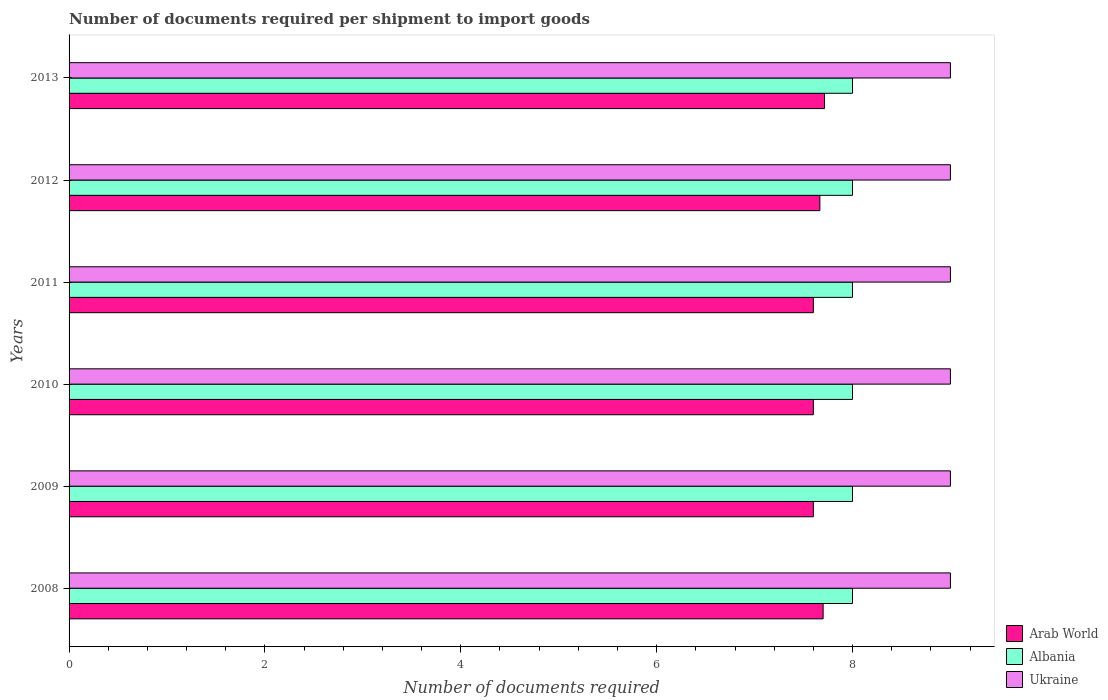How many different coloured bars are there?
Your response must be concise. 3. How many groups of bars are there?
Your response must be concise. 6. Are the number of bars per tick equal to the number of legend labels?
Ensure brevity in your answer.  Yes. What is the number of documents required per shipment to import goods in Ukraine in 2012?
Keep it short and to the point. 9. Across all years, what is the maximum number of documents required per shipment to import goods in Arab World?
Provide a short and direct response. 7.71. Across all years, what is the minimum number of documents required per shipment to import goods in Ukraine?
Your answer should be very brief. 9. In which year was the number of documents required per shipment to import goods in Ukraine maximum?
Provide a succinct answer. 2008. What is the total number of documents required per shipment to import goods in Albania in the graph?
Provide a short and direct response. 48. What is the difference between the number of documents required per shipment to import goods in Arab World in 2009 and that in 2012?
Provide a succinct answer. -0.07. What is the difference between the number of documents required per shipment to import goods in Albania in 2009 and the number of documents required per shipment to import goods in Ukraine in 2013?
Your response must be concise. -1. What is the average number of documents required per shipment to import goods in Arab World per year?
Provide a succinct answer. 7.65. In the year 2008, what is the difference between the number of documents required per shipment to import goods in Ukraine and number of documents required per shipment to import goods in Albania?
Your answer should be very brief. 1. In how many years, is the number of documents required per shipment to import goods in Arab World greater than 1.2000000000000002 ?
Give a very brief answer. 6. What is the ratio of the number of documents required per shipment to import goods in Ukraine in 2009 to that in 2012?
Keep it short and to the point. 1. What is the difference between the highest and the second highest number of documents required per shipment to import goods in Arab World?
Your answer should be compact. 0.01. What is the difference between the highest and the lowest number of documents required per shipment to import goods in Ukraine?
Make the answer very short. 0. Is the sum of the number of documents required per shipment to import goods in Arab World in 2009 and 2012 greater than the maximum number of documents required per shipment to import goods in Ukraine across all years?
Provide a succinct answer. Yes. What does the 1st bar from the top in 2008 represents?
Your response must be concise. Ukraine. What does the 1st bar from the bottom in 2011 represents?
Your answer should be very brief. Arab World. Are the values on the major ticks of X-axis written in scientific E-notation?
Offer a very short reply. No. Does the graph contain grids?
Offer a terse response. No. Where does the legend appear in the graph?
Provide a succinct answer. Bottom right. What is the title of the graph?
Your answer should be compact. Number of documents required per shipment to import goods. What is the label or title of the X-axis?
Keep it short and to the point. Number of documents required. What is the Number of documents required in Albania in 2008?
Provide a succinct answer. 8. What is the Number of documents required in Ukraine in 2008?
Provide a succinct answer. 9. What is the Number of documents required in Arab World in 2009?
Offer a very short reply. 7.6. What is the Number of documents required in Albania in 2009?
Give a very brief answer. 8. What is the Number of documents required of Arab World in 2011?
Your response must be concise. 7.6. What is the Number of documents required in Albania in 2011?
Make the answer very short. 8. What is the Number of documents required in Ukraine in 2011?
Provide a succinct answer. 9. What is the Number of documents required of Arab World in 2012?
Provide a short and direct response. 7.67. What is the Number of documents required in Arab World in 2013?
Give a very brief answer. 7.71. What is the Number of documents required of Ukraine in 2013?
Your answer should be compact. 9. Across all years, what is the maximum Number of documents required in Arab World?
Give a very brief answer. 7.71. Across all years, what is the maximum Number of documents required of Albania?
Your response must be concise. 8. Across all years, what is the maximum Number of documents required in Ukraine?
Provide a short and direct response. 9. What is the total Number of documents required in Arab World in the graph?
Offer a terse response. 45.88. What is the total Number of documents required in Albania in the graph?
Keep it short and to the point. 48. What is the difference between the Number of documents required in Arab World in 2008 and that in 2010?
Provide a succinct answer. 0.1. What is the difference between the Number of documents required of Arab World in 2008 and that in 2011?
Offer a terse response. 0.1. What is the difference between the Number of documents required in Arab World in 2008 and that in 2012?
Your answer should be very brief. 0.03. What is the difference between the Number of documents required of Arab World in 2008 and that in 2013?
Your answer should be very brief. -0.01. What is the difference between the Number of documents required of Albania in 2008 and that in 2013?
Make the answer very short. 0. What is the difference between the Number of documents required in Ukraine in 2008 and that in 2013?
Your response must be concise. 0. What is the difference between the Number of documents required of Ukraine in 2009 and that in 2010?
Your response must be concise. 0. What is the difference between the Number of documents required in Arab World in 2009 and that in 2011?
Give a very brief answer. 0. What is the difference between the Number of documents required of Arab World in 2009 and that in 2012?
Keep it short and to the point. -0.07. What is the difference between the Number of documents required of Albania in 2009 and that in 2012?
Provide a short and direct response. 0. What is the difference between the Number of documents required of Arab World in 2009 and that in 2013?
Make the answer very short. -0.11. What is the difference between the Number of documents required in Albania in 2009 and that in 2013?
Make the answer very short. 0. What is the difference between the Number of documents required of Arab World in 2010 and that in 2011?
Keep it short and to the point. 0. What is the difference between the Number of documents required of Albania in 2010 and that in 2011?
Provide a succinct answer. 0. What is the difference between the Number of documents required of Arab World in 2010 and that in 2012?
Provide a short and direct response. -0.07. What is the difference between the Number of documents required of Arab World in 2010 and that in 2013?
Your answer should be compact. -0.11. What is the difference between the Number of documents required in Ukraine in 2010 and that in 2013?
Your response must be concise. 0. What is the difference between the Number of documents required in Arab World in 2011 and that in 2012?
Provide a short and direct response. -0.07. What is the difference between the Number of documents required in Albania in 2011 and that in 2012?
Ensure brevity in your answer.  0. What is the difference between the Number of documents required in Arab World in 2011 and that in 2013?
Provide a succinct answer. -0.11. What is the difference between the Number of documents required of Ukraine in 2011 and that in 2013?
Ensure brevity in your answer.  0. What is the difference between the Number of documents required in Arab World in 2012 and that in 2013?
Keep it short and to the point. -0.05. What is the difference between the Number of documents required of Ukraine in 2012 and that in 2013?
Make the answer very short. 0. What is the difference between the Number of documents required of Albania in 2008 and the Number of documents required of Ukraine in 2009?
Your answer should be very brief. -1. What is the difference between the Number of documents required of Arab World in 2008 and the Number of documents required of Albania in 2010?
Make the answer very short. -0.3. What is the difference between the Number of documents required of Arab World in 2008 and the Number of documents required of Ukraine in 2011?
Offer a terse response. -1.3. What is the difference between the Number of documents required of Albania in 2008 and the Number of documents required of Ukraine in 2011?
Offer a very short reply. -1. What is the difference between the Number of documents required of Arab World in 2008 and the Number of documents required of Ukraine in 2012?
Ensure brevity in your answer.  -1.3. What is the difference between the Number of documents required in Albania in 2008 and the Number of documents required in Ukraine in 2012?
Keep it short and to the point. -1. What is the difference between the Number of documents required of Arab World in 2008 and the Number of documents required of Ukraine in 2013?
Your response must be concise. -1.3. What is the difference between the Number of documents required in Arab World in 2009 and the Number of documents required in Albania in 2010?
Provide a short and direct response. -0.4. What is the difference between the Number of documents required of Arab World in 2009 and the Number of documents required of Ukraine in 2011?
Your answer should be compact. -1.4. What is the difference between the Number of documents required of Albania in 2009 and the Number of documents required of Ukraine in 2011?
Provide a short and direct response. -1. What is the difference between the Number of documents required of Arab World in 2009 and the Number of documents required of Albania in 2012?
Your answer should be compact. -0.4. What is the difference between the Number of documents required in Arab World in 2009 and the Number of documents required in Ukraine in 2012?
Keep it short and to the point. -1.4. What is the difference between the Number of documents required in Albania in 2009 and the Number of documents required in Ukraine in 2012?
Make the answer very short. -1. What is the difference between the Number of documents required of Arab World in 2009 and the Number of documents required of Albania in 2013?
Offer a very short reply. -0.4. What is the difference between the Number of documents required in Arab World in 2009 and the Number of documents required in Ukraine in 2013?
Offer a terse response. -1.4. What is the difference between the Number of documents required of Albania in 2009 and the Number of documents required of Ukraine in 2013?
Offer a terse response. -1. What is the difference between the Number of documents required in Arab World in 2010 and the Number of documents required in Albania in 2011?
Give a very brief answer. -0.4. What is the difference between the Number of documents required of Albania in 2010 and the Number of documents required of Ukraine in 2011?
Keep it short and to the point. -1. What is the difference between the Number of documents required in Arab World in 2010 and the Number of documents required in Albania in 2012?
Ensure brevity in your answer.  -0.4. What is the difference between the Number of documents required of Albania in 2010 and the Number of documents required of Ukraine in 2012?
Your response must be concise. -1. What is the difference between the Number of documents required of Arab World in 2011 and the Number of documents required of Albania in 2012?
Provide a short and direct response. -0.4. What is the difference between the Number of documents required in Albania in 2011 and the Number of documents required in Ukraine in 2012?
Offer a very short reply. -1. What is the difference between the Number of documents required in Arab World in 2011 and the Number of documents required in Albania in 2013?
Offer a very short reply. -0.4. What is the difference between the Number of documents required of Arab World in 2011 and the Number of documents required of Ukraine in 2013?
Offer a terse response. -1.4. What is the difference between the Number of documents required in Albania in 2011 and the Number of documents required in Ukraine in 2013?
Give a very brief answer. -1. What is the difference between the Number of documents required of Arab World in 2012 and the Number of documents required of Albania in 2013?
Offer a terse response. -0.33. What is the difference between the Number of documents required of Arab World in 2012 and the Number of documents required of Ukraine in 2013?
Offer a terse response. -1.33. What is the average Number of documents required in Arab World per year?
Offer a very short reply. 7.65. What is the average Number of documents required in Albania per year?
Your answer should be compact. 8. In the year 2009, what is the difference between the Number of documents required in Arab World and Number of documents required in Albania?
Offer a very short reply. -0.4. In the year 2009, what is the difference between the Number of documents required in Arab World and Number of documents required in Ukraine?
Offer a very short reply. -1.4. In the year 2010, what is the difference between the Number of documents required of Arab World and Number of documents required of Ukraine?
Your response must be concise. -1.4. In the year 2012, what is the difference between the Number of documents required of Arab World and Number of documents required of Albania?
Your response must be concise. -0.33. In the year 2012, what is the difference between the Number of documents required of Arab World and Number of documents required of Ukraine?
Make the answer very short. -1.33. In the year 2012, what is the difference between the Number of documents required of Albania and Number of documents required of Ukraine?
Ensure brevity in your answer.  -1. In the year 2013, what is the difference between the Number of documents required in Arab World and Number of documents required in Albania?
Make the answer very short. -0.29. In the year 2013, what is the difference between the Number of documents required in Arab World and Number of documents required in Ukraine?
Give a very brief answer. -1.29. In the year 2013, what is the difference between the Number of documents required of Albania and Number of documents required of Ukraine?
Provide a succinct answer. -1. What is the ratio of the Number of documents required in Arab World in 2008 to that in 2009?
Keep it short and to the point. 1.01. What is the ratio of the Number of documents required in Albania in 2008 to that in 2009?
Your answer should be very brief. 1. What is the ratio of the Number of documents required in Ukraine in 2008 to that in 2009?
Ensure brevity in your answer.  1. What is the ratio of the Number of documents required in Arab World in 2008 to that in 2010?
Give a very brief answer. 1.01. What is the ratio of the Number of documents required in Ukraine in 2008 to that in 2010?
Offer a terse response. 1. What is the ratio of the Number of documents required of Arab World in 2008 to that in 2011?
Give a very brief answer. 1.01. What is the ratio of the Number of documents required of Ukraine in 2008 to that in 2011?
Provide a short and direct response. 1. What is the ratio of the Number of documents required of Albania in 2008 to that in 2012?
Your response must be concise. 1. What is the ratio of the Number of documents required in Arab World in 2008 to that in 2013?
Ensure brevity in your answer.  1. What is the ratio of the Number of documents required in Albania in 2008 to that in 2013?
Ensure brevity in your answer.  1. What is the ratio of the Number of documents required of Ukraine in 2008 to that in 2013?
Provide a succinct answer. 1. What is the ratio of the Number of documents required in Albania in 2009 to that in 2010?
Provide a short and direct response. 1. What is the ratio of the Number of documents required of Ukraine in 2009 to that in 2012?
Provide a short and direct response. 1. What is the ratio of the Number of documents required of Arab World in 2009 to that in 2013?
Offer a very short reply. 0.99. What is the ratio of the Number of documents required of Arab World in 2010 to that in 2011?
Your answer should be compact. 1. What is the ratio of the Number of documents required of Albania in 2010 to that in 2011?
Provide a short and direct response. 1. What is the ratio of the Number of documents required in Arab World in 2010 to that in 2013?
Offer a terse response. 0.99. What is the ratio of the Number of documents required of Albania in 2010 to that in 2013?
Offer a very short reply. 1. What is the ratio of the Number of documents required of Arab World in 2011 to that in 2012?
Your answer should be compact. 0.99. What is the ratio of the Number of documents required of Ukraine in 2011 to that in 2012?
Your response must be concise. 1. What is the ratio of the Number of documents required in Arab World in 2011 to that in 2013?
Make the answer very short. 0.99. What is the ratio of the Number of documents required of Albania in 2011 to that in 2013?
Your answer should be very brief. 1. What is the ratio of the Number of documents required in Ukraine in 2011 to that in 2013?
Your response must be concise. 1. What is the ratio of the Number of documents required in Arab World in 2012 to that in 2013?
Offer a terse response. 0.99. What is the difference between the highest and the second highest Number of documents required of Arab World?
Offer a terse response. 0.01. What is the difference between the highest and the second highest Number of documents required in Albania?
Offer a very short reply. 0. What is the difference between the highest and the second highest Number of documents required of Ukraine?
Keep it short and to the point. 0. What is the difference between the highest and the lowest Number of documents required in Arab World?
Give a very brief answer. 0.11. What is the difference between the highest and the lowest Number of documents required of Albania?
Offer a very short reply. 0. 